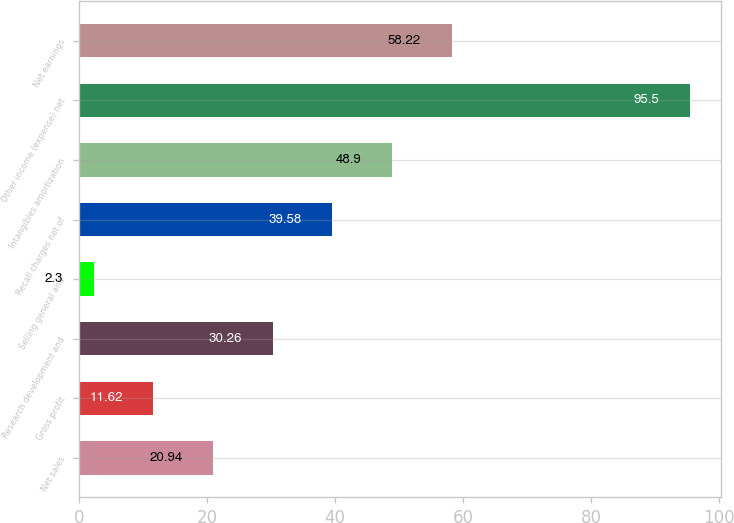Convert chart to OTSL. <chart><loc_0><loc_0><loc_500><loc_500><bar_chart><fcel>Net sales<fcel>Gross profit<fcel>Research development and<fcel>Selling general and<fcel>Recall charges net of<fcel>Intangibles amortization<fcel>Other income (expense) net<fcel>Net earnings<nl><fcel>20.94<fcel>11.62<fcel>30.26<fcel>2.3<fcel>39.58<fcel>48.9<fcel>95.5<fcel>58.22<nl></chart> 